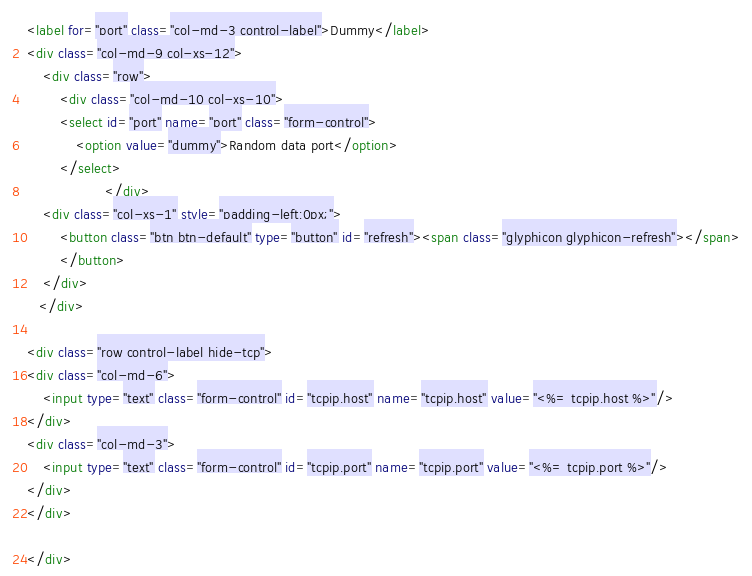Convert code to text. <code><loc_0><loc_0><loc_500><loc_500><_HTML_><label for="port" class="col-md-3 control-label">Dummy</label>
<div class="col-md-9 col-xs-12">
    <div class="row">
        <div class="col-md-10 col-xs-10">
        <select id="port" name="port" class="form-control">
            <option value="dummy">Random data port</option>
        </select>
                   </div>
    <div class="col-xs-1" style="padding-left:0px;">
        <button class="btn btn-default" type="button" id="refresh"><span class="glyphicon glyphicon-refresh"></span>
        </button>
    </div>
   </div>

<div class="row control-label hide-tcp">
<div class="col-md-6">
    <input type="text" class="form-control" id="tcpip.host" name="tcpip.host" value="<%= tcpip.host %>"/>
</div>
<div class="col-md-3">
    <input type="text" class="form-control" id="tcpip.port" name="tcpip.port" value="<%= tcpip.port %>"/>
</div>
</div>

</div></code> 